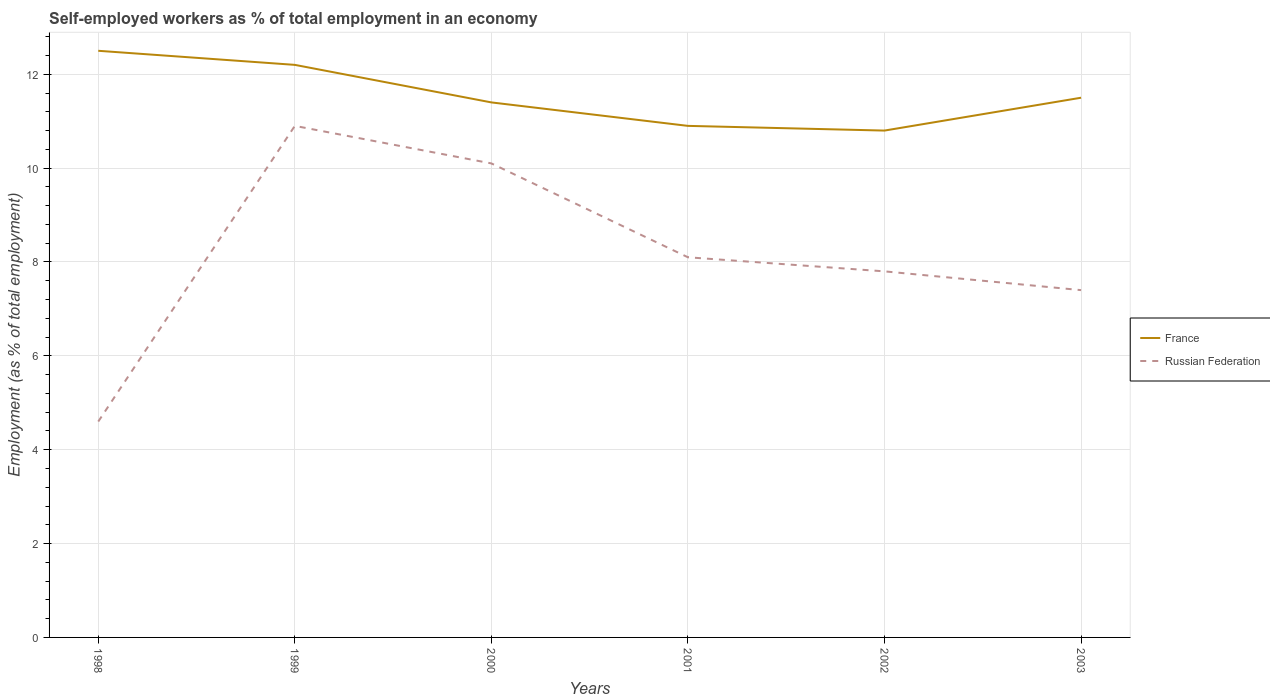Does the line corresponding to France intersect with the line corresponding to Russian Federation?
Give a very brief answer. No. Across all years, what is the maximum percentage of self-employed workers in France?
Provide a succinct answer. 10.8. In which year was the percentage of self-employed workers in France maximum?
Provide a short and direct response. 2002. What is the total percentage of self-employed workers in France in the graph?
Ensure brevity in your answer.  -0.1. What is the difference between the highest and the second highest percentage of self-employed workers in France?
Keep it short and to the point. 1.7. Is the percentage of self-employed workers in Russian Federation strictly greater than the percentage of self-employed workers in France over the years?
Your answer should be compact. Yes. Are the values on the major ticks of Y-axis written in scientific E-notation?
Make the answer very short. No. Does the graph contain grids?
Your response must be concise. Yes. What is the title of the graph?
Your answer should be very brief. Self-employed workers as % of total employment in an economy. What is the label or title of the Y-axis?
Offer a terse response. Employment (as % of total employment). What is the Employment (as % of total employment) in Russian Federation in 1998?
Your response must be concise. 4.6. What is the Employment (as % of total employment) of France in 1999?
Make the answer very short. 12.2. What is the Employment (as % of total employment) in Russian Federation in 1999?
Your response must be concise. 10.9. What is the Employment (as % of total employment) of France in 2000?
Offer a terse response. 11.4. What is the Employment (as % of total employment) of Russian Federation in 2000?
Give a very brief answer. 10.1. What is the Employment (as % of total employment) of France in 2001?
Offer a terse response. 10.9. What is the Employment (as % of total employment) in Russian Federation in 2001?
Make the answer very short. 8.1. What is the Employment (as % of total employment) in France in 2002?
Your response must be concise. 10.8. What is the Employment (as % of total employment) in Russian Federation in 2002?
Your response must be concise. 7.8. What is the Employment (as % of total employment) in Russian Federation in 2003?
Provide a succinct answer. 7.4. Across all years, what is the maximum Employment (as % of total employment) of Russian Federation?
Ensure brevity in your answer.  10.9. Across all years, what is the minimum Employment (as % of total employment) in France?
Make the answer very short. 10.8. Across all years, what is the minimum Employment (as % of total employment) of Russian Federation?
Make the answer very short. 4.6. What is the total Employment (as % of total employment) of France in the graph?
Provide a succinct answer. 69.3. What is the total Employment (as % of total employment) in Russian Federation in the graph?
Provide a succinct answer. 48.9. What is the difference between the Employment (as % of total employment) of France in 1998 and that in 2001?
Ensure brevity in your answer.  1.6. What is the difference between the Employment (as % of total employment) in France in 1998 and that in 2002?
Give a very brief answer. 1.7. What is the difference between the Employment (as % of total employment) of Russian Federation in 1999 and that in 2000?
Provide a short and direct response. 0.8. What is the difference between the Employment (as % of total employment) in France in 1999 and that in 2001?
Provide a succinct answer. 1.3. What is the difference between the Employment (as % of total employment) in France in 1999 and that in 2003?
Ensure brevity in your answer.  0.7. What is the difference between the Employment (as % of total employment) of Russian Federation in 1999 and that in 2003?
Make the answer very short. 3.5. What is the difference between the Employment (as % of total employment) of Russian Federation in 2000 and that in 2001?
Ensure brevity in your answer.  2. What is the difference between the Employment (as % of total employment) of France in 2000 and that in 2002?
Your answer should be compact. 0.6. What is the difference between the Employment (as % of total employment) of Russian Federation in 2000 and that in 2003?
Your answer should be compact. 2.7. What is the difference between the Employment (as % of total employment) of Russian Federation in 2001 and that in 2002?
Provide a short and direct response. 0.3. What is the difference between the Employment (as % of total employment) of France in 1998 and the Employment (as % of total employment) of Russian Federation in 2000?
Offer a terse response. 2.4. What is the difference between the Employment (as % of total employment) in France in 1998 and the Employment (as % of total employment) in Russian Federation in 2001?
Provide a short and direct response. 4.4. What is the difference between the Employment (as % of total employment) of France in 1998 and the Employment (as % of total employment) of Russian Federation in 2002?
Offer a very short reply. 4.7. What is the difference between the Employment (as % of total employment) in France in 1999 and the Employment (as % of total employment) in Russian Federation in 2000?
Keep it short and to the point. 2.1. What is the difference between the Employment (as % of total employment) in France in 1999 and the Employment (as % of total employment) in Russian Federation in 2001?
Give a very brief answer. 4.1. What is the difference between the Employment (as % of total employment) in France in 1999 and the Employment (as % of total employment) in Russian Federation in 2003?
Offer a very short reply. 4.8. What is the difference between the Employment (as % of total employment) in France in 2000 and the Employment (as % of total employment) in Russian Federation in 2001?
Give a very brief answer. 3.3. What is the difference between the Employment (as % of total employment) in France in 2000 and the Employment (as % of total employment) in Russian Federation in 2002?
Make the answer very short. 3.6. What is the difference between the Employment (as % of total employment) of France in 2000 and the Employment (as % of total employment) of Russian Federation in 2003?
Provide a succinct answer. 4. What is the average Employment (as % of total employment) of France per year?
Your response must be concise. 11.55. What is the average Employment (as % of total employment) in Russian Federation per year?
Give a very brief answer. 8.15. In the year 1999, what is the difference between the Employment (as % of total employment) of France and Employment (as % of total employment) of Russian Federation?
Provide a short and direct response. 1.3. In the year 2002, what is the difference between the Employment (as % of total employment) in France and Employment (as % of total employment) in Russian Federation?
Offer a terse response. 3. In the year 2003, what is the difference between the Employment (as % of total employment) in France and Employment (as % of total employment) in Russian Federation?
Keep it short and to the point. 4.1. What is the ratio of the Employment (as % of total employment) of France in 1998 to that in 1999?
Your answer should be compact. 1.02. What is the ratio of the Employment (as % of total employment) in Russian Federation in 1998 to that in 1999?
Provide a succinct answer. 0.42. What is the ratio of the Employment (as % of total employment) in France in 1998 to that in 2000?
Provide a succinct answer. 1.1. What is the ratio of the Employment (as % of total employment) in Russian Federation in 1998 to that in 2000?
Your answer should be very brief. 0.46. What is the ratio of the Employment (as % of total employment) of France in 1998 to that in 2001?
Your answer should be very brief. 1.15. What is the ratio of the Employment (as % of total employment) of Russian Federation in 1998 to that in 2001?
Your answer should be very brief. 0.57. What is the ratio of the Employment (as % of total employment) of France in 1998 to that in 2002?
Your response must be concise. 1.16. What is the ratio of the Employment (as % of total employment) in Russian Federation in 1998 to that in 2002?
Ensure brevity in your answer.  0.59. What is the ratio of the Employment (as % of total employment) in France in 1998 to that in 2003?
Your answer should be compact. 1.09. What is the ratio of the Employment (as % of total employment) of Russian Federation in 1998 to that in 2003?
Your answer should be compact. 0.62. What is the ratio of the Employment (as % of total employment) in France in 1999 to that in 2000?
Give a very brief answer. 1.07. What is the ratio of the Employment (as % of total employment) in Russian Federation in 1999 to that in 2000?
Ensure brevity in your answer.  1.08. What is the ratio of the Employment (as % of total employment) of France in 1999 to that in 2001?
Give a very brief answer. 1.12. What is the ratio of the Employment (as % of total employment) in Russian Federation in 1999 to that in 2001?
Keep it short and to the point. 1.35. What is the ratio of the Employment (as % of total employment) in France in 1999 to that in 2002?
Provide a succinct answer. 1.13. What is the ratio of the Employment (as % of total employment) in Russian Federation in 1999 to that in 2002?
Your answer should be very brief. 1.4. What is the ratio of the Employment (as % of total employment) of France in 1999 to that in 2003?
Offer a terse response. 1.06. What is the ratio of the Employment (as % of total employment) of Russian Federation in 1999 to that in 2003?
Offer a terse response. 1.47. What is the ratio of the Employment (as % of total employment) of France in 2000 to that in 2001?
Make the answer very short. 1.05. What is the ratio of the Employment (as % of total employment) of Russian Federation in 2000 to that in 2001?
Ensure brevity in your answer.  1.25. What is the ratio of the Employment (as % of total employment) of France in 2000 to that in 2002?
Keep it short and to the point. 1.06. What is the ratio of the Employment (as % of total employment) of Russian Federation in 2000 to that in 2002?
Your response must be concise. 1.29. What is the ratio of the Employment (as % of total employment) of France in 2000 to that in 2003?
Provide a short and direct response. 0.99. What is the ratio of the Employment (as % of total employment) of Russian Federation in 2000 to that in 2003?
Ensure brevity in your answer.  1.36. What is the ratio of the Employment (as % of total employment) of France in 2001 to that in 2002?
Ensure brevity in your answer.  1.01. What is the ratio of the Employment (as % of total employment) of Russian Federation in 2001 to that in 2002?
Provide a short and direct response. 1.04. What is the ratio of the Employment (as % of total employment) in France in 2001 to that in 2003?
Offer a very short reply. 0.95. What is the ratio of the Employment (as % of total employment) of Russian Federation in 2001 to that in 2003?
Provide a succinct answer. 1.09. What is the ratio of the Employment (as % of total employment) of France in 2002 to that in 2003?
Offer a very short reply. 0.94. What is the ratio of the Employment (as % of total employment) of Russian Federation in 2002 to that in 2003?
Ensure brevity in your answer.  1.05. What is the difference between the highest and the second highest Employment (as % of total employment) of France?
Offer a terse response. 0.3. What is the difference between the highest and the second highest Employment (as % of total employment) in Russian Federation?
Provide a succinct answer. 0.8. What is the difference between the highest and the lowest Employment (as % of total employment) of Russian Federation?
Your answer should be very brief. 6.3. 